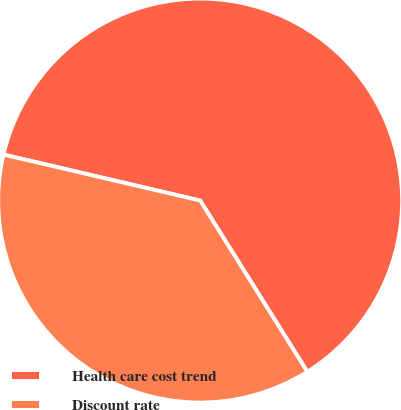Convert chart to OTSL. <chart><loc_0><loc_0><loc_500><loc_500><pie_chart><fcel>Health care cost trend<fcel>Discount rate<nl><fcel>62.44%<fcel>37.56%<nl></chart> 